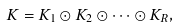Convert formula to latex. <formula><loc_0><loc_0><loc_500><loc_500>K = K _ { 1 } \odot K _ { 2 } \odot \dots \odot K _ { R } ,</formula> 